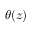<formula> <loc_0><loc_0><loc_500><loc_500>\theta ( z )</formula> 